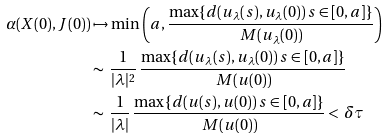Convert formula to latex. <formula><loc_0><loc_0><loc_500><loc_500>\alpha ( X ( 0 ) , J ( 0 ) ) & \mapsto \min \left ( a , \frac { \max \{ d ( u _ { \lambda } ( s ) , u _ { \lambda } ( 0 ) ) \, s \in [ 0 , a ] \} } { \, M ( u _ { \lambda } ( 0 ) ) } \right ) \\ & \sim \, \frac { 1 } { | \lambda | ^ { 2 } } \, \frac { \max \{ d ( u _ { \lambda } ( s ) , u _ { \lambda } ( 0 ) ) \, s \in [ 0 , a ] \} } { \, M ( u ( 0 ) ) } \\ & \sim \, \frac { 1 } { | \lambda | } \, \frac { \max \{ d ( u ( s ) , u ( 0 ) ) \, s \in [ 0 , a ] \} } { \, M ( u ( 0 ) ) } < \, \delta \tau</formula> 